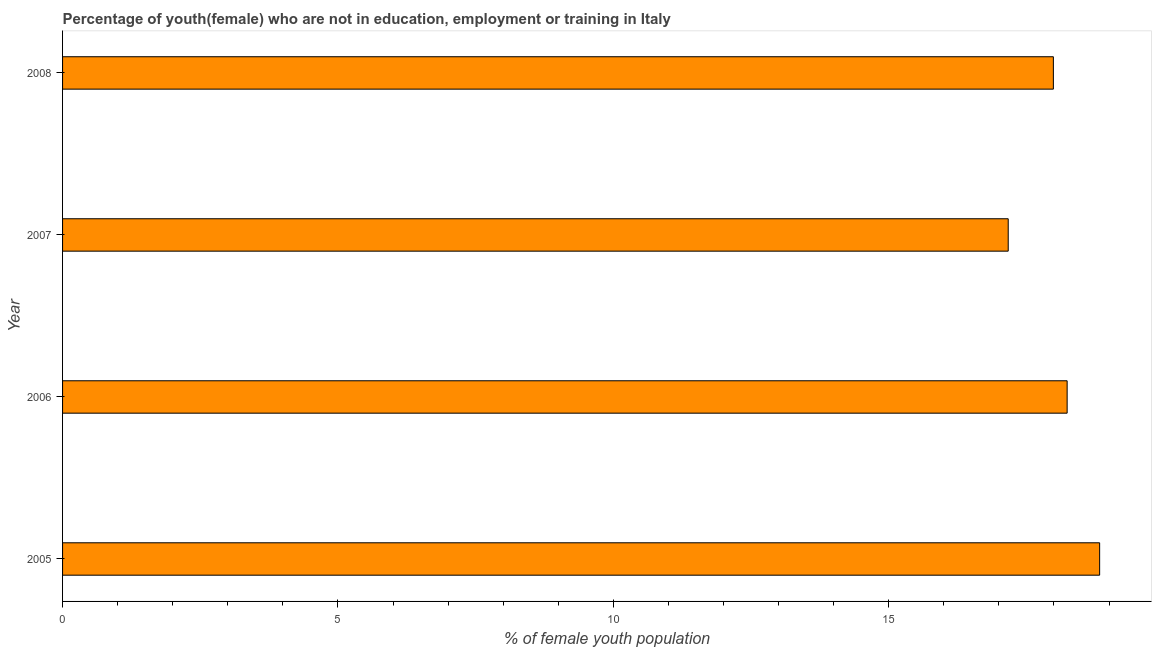Does the graph contain any zero values?
Provide a succinct answer. No. Does the graph contain grids?
Offer a terse response. No. What is the title of the graph?
Your answer should be compact. Percentage of youth(female) who are not in education, employment or training in Italy. What is the label or title of the X-axis?
Your answer should be compact. % of female youth population. What is the unemployed female youth population in 2008?
Keep it short and to the point. 17.99. Across all years, what is the maximum unemployed female youth population?
Your answer should be compact. 18.83. Across all years, what is the minimum unemployed female youth population?
Provide a succinct answer. 17.17. In which year was the unemployed female youth population maximum?
Keep it short and to the point. 2005. What is the sum of the unemployed female youth population?
Provide a short and direct response. 72.23. What is the difference between the unemployed female youth population in 2005 and 2008?
Your response must be concise. 0.84. What is the average unemployed female youth population per year?
Your answer should be compact. 18.06. What is the median unemployed female youth population?
Ensure brevity in your answer.  18.11. Is the difference between the unemployed female youth population in 2007 and 2008 greater than the difference between any two years?
Your answer should be compact. No. What is the difference between the highest and the second highest unemployed female youth population?
Make the answer very short. 0.59. Is the sum of the unemployed female youth population in 2006 and 2007 greater than the maximum unemployed female youth population across all years?
Offer a very short reply. Yes. What is the difference between the highest and the lowest unemployed female youth population?
Keep it short and to the point. 1.66. In how many years, is the unemployed female youth population greater than the average unemployed female youth population taken over all years?
Keep it short and to the point. 2. Are all the bars in the graph horizontal?
Ensure brevity in your answer.  Yes. How many years are there in the graph?
Ensure brevity in your answer.  4. What is the % of female youth population in 2005?
Your response must be concise. 18.83. What is the % of female youth population in 2006?
Your answer should be very brief. 18.24. What is the % of female youth population of 2007?
Provide a succinct answer. 17.17. What is the % of female youth population of 2008?
Your answer should be compact. 17.99. What is the difference between the % of female youth population in 2005 and 2006?
Provide a short and direct response. 0.59. What is the difference between the % of female youth population in 2005 and 2007?
Give a very brief answer. 1.66. What is the difference between the % of female youth population in 2005 and 2008?
Offer a terse response. 0.84. What is the difference between the % of female youth population in 2006 and 2007?
Offer a terse response. 1.07. What is the difference between the % of female youth population in 2006 and 2008?
Provide a short and direct response. 0.25. What is the difference between the % of female youth population in 2007 and 2008?
Ensure brevity in your answer.  -0.82. What is the ratio of the % of female youth population in 2005 to that in 2006?
Your answer should be very brief. 1.03. What is the ratio of the % of female youth population in 2005 to that in 2007?
Ensure brevity in your answer.  1.1. What is the ratio of the % of female youth population in 2005 to that in 2008?
Your answer should be compact. 1.05. What is the ratio of the % of female youth population in 2006 to that in 2007?
Make the answer very short. 1.06. What is the ratio of the % of female youth population in 2006 to that in 2008?
Give a very brief answer. 1.01. What is the ratio of the % of female youth population in 2007 to that in 2008?
Your answer should be compact. 0.95. 